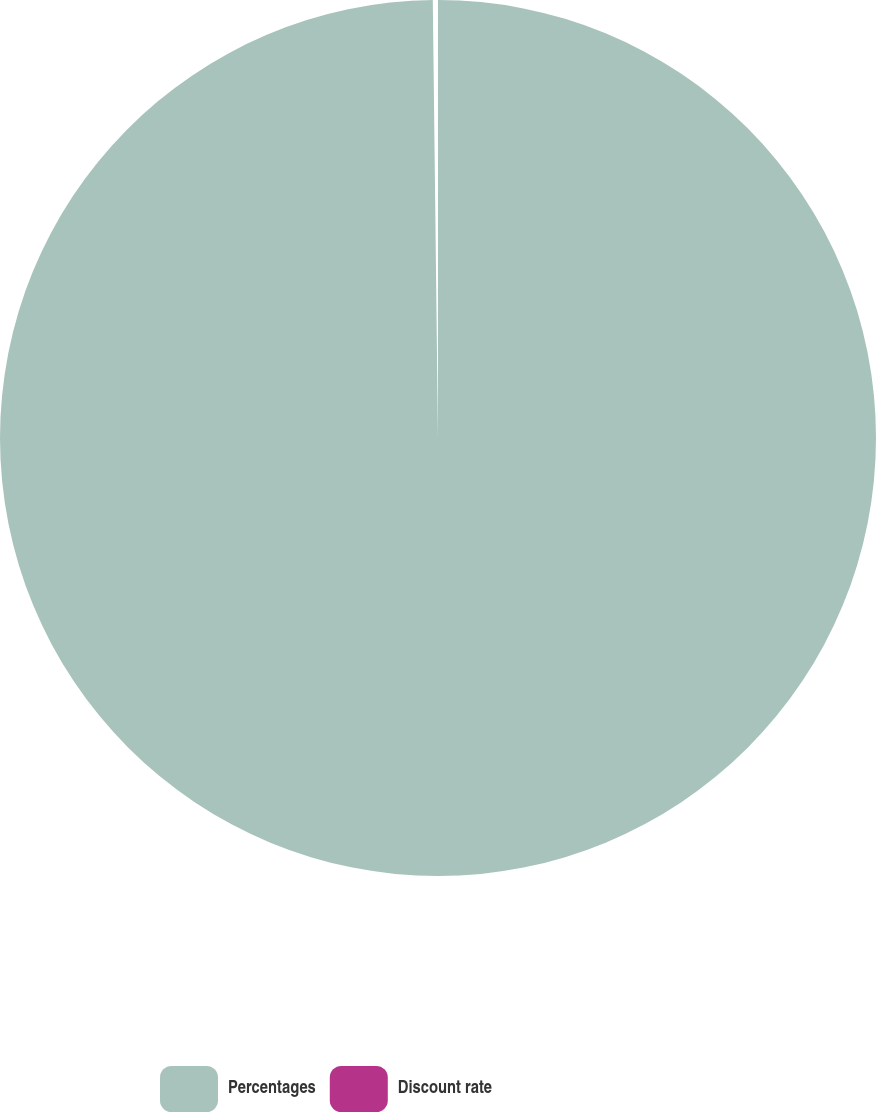Convert chart to OTSL. <chart><loc_0><loc_0><loc_500><loc_500><pie_chart><fcel>Percentages<fcel>Discount rate<nl><fcel>99.81%<fcel>0.19%<nl></chart> 